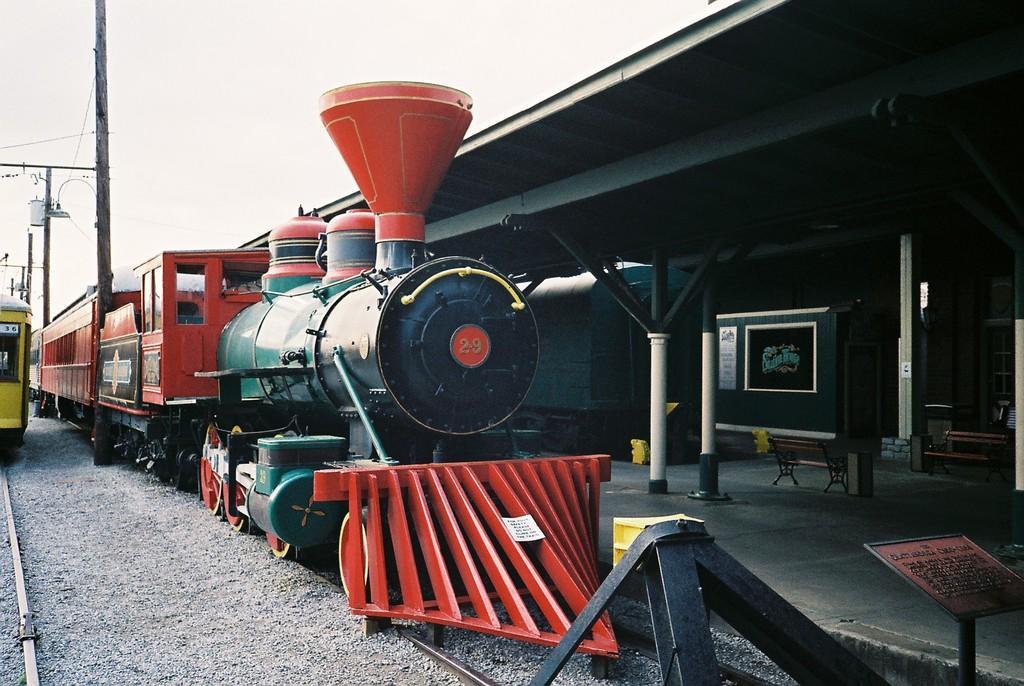Please provide a concise description of this image. In this picture I can see trains on the railway tracks. I can see the platform on the right side. I can see clouds in the sky. 